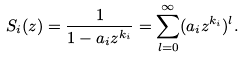Convert formula to latex. <formula><loc_0><loc_0><loc_500><loc_500>S _ { i } ( z ) = \frac { 1 } { 1 - a _ { i } z ^ { k _ { i } } } = \sum _ { l = 0 } ^ { \infty } ( a _ { i } z ^ { k _ { i } } ) ^ { l } .</formula> 